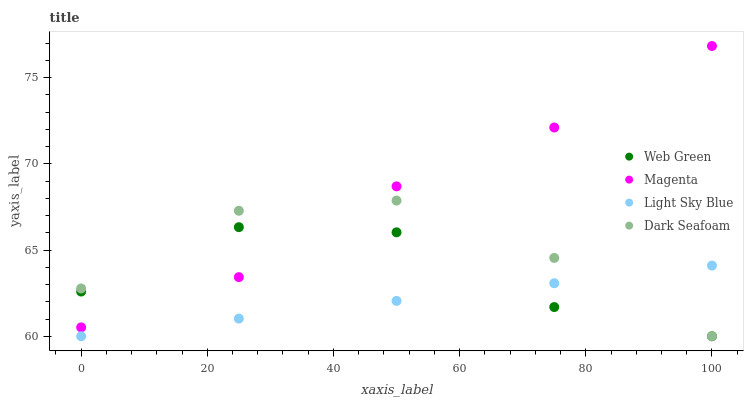Does Light Sky Blue have the minimum area under the curve?
Answer yes or no. Yes. Does Magenta have the maximum area under the curve?
Answer yes or no. Yes. Does Dark Seafoam have the minimum area under the curve?
Answer yes or no. No. Does Dark Seafoam have the maximum area under the curve?
Answer yes or no. No. Is Light Sky Blue the smoothest?
Answer yes or no. Yes. Is Web Green the roughest?
Answer yes or no. Yes. Is Dark Seafoam the smoothest?
Answer yes or no. No. Is Dark Seafoam the roughest?
Answer yes or no. No. Does Light Sky Blue have the lowest value?
Answer yes or no. Yes. Does Magenta have the highest value?
Answer yes or no. Yes. Does Dark Seafoam have the highest value?
Answer yes or no. No. Is Light Sky Blue less than Magenta?
Answer yes or no. Yes. Is Magenta greater than Light Sky Blue?
Answer yes or no. Yes. Does Web Green intersect Magenta?
Answer yes or no. Yes. Is Web Green less than Magenta?
Answer yes or no. No. Is Web Green greater than Magenta?
Answer yes or no. No. Does Light Sky Blue intersect Magenta?
Answer yes or no. No. 